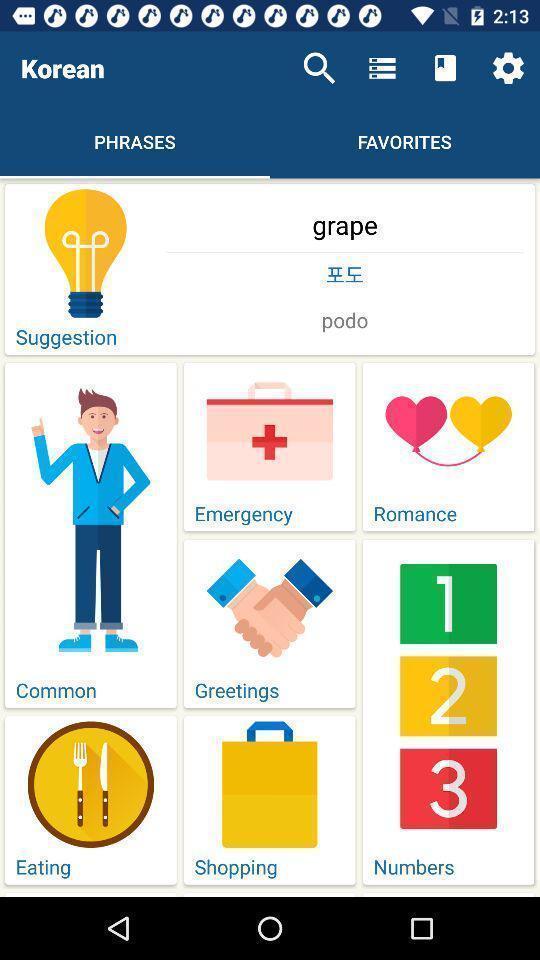Give me a summary of this screen capture. Screen displaying list of features. 